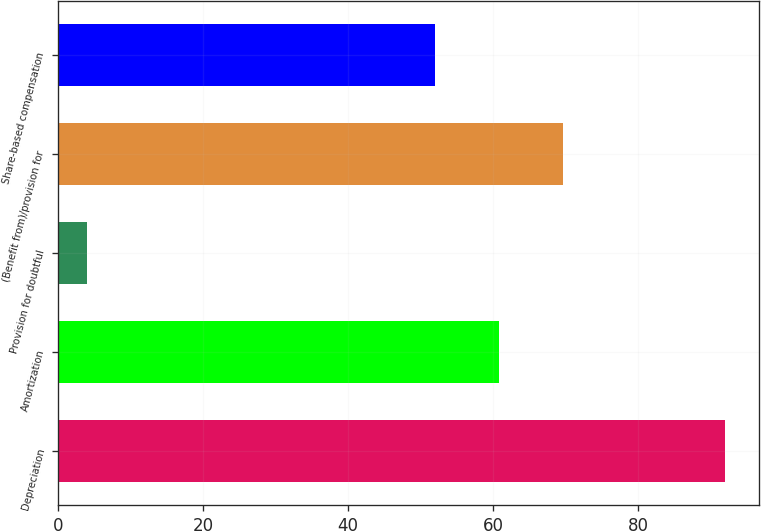Convert chart to OTSL. <chart><loc_0><loc_0><loc_500><loc_500><bar_chart><fcel>Depreciation<fcel>Amortization<fcel>Provision for doubtful<fcel>(Benefit from)/provision for<fcel>Share-based compensation<nl><fcel>92<fcel>60.8<fcel>4<fcel>69.6<fcel>52<nl></chart> 